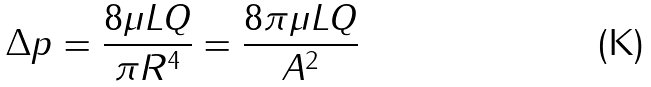<formula> <loc_0><loc_0><loc_500><loc_500>\Delta p = { \frac { 8 \mu L Q } { \pi R ^ { 4 } } } = { \frac { 8 \pi \mu L Q } { A ^ { 2 } } }</formula> 